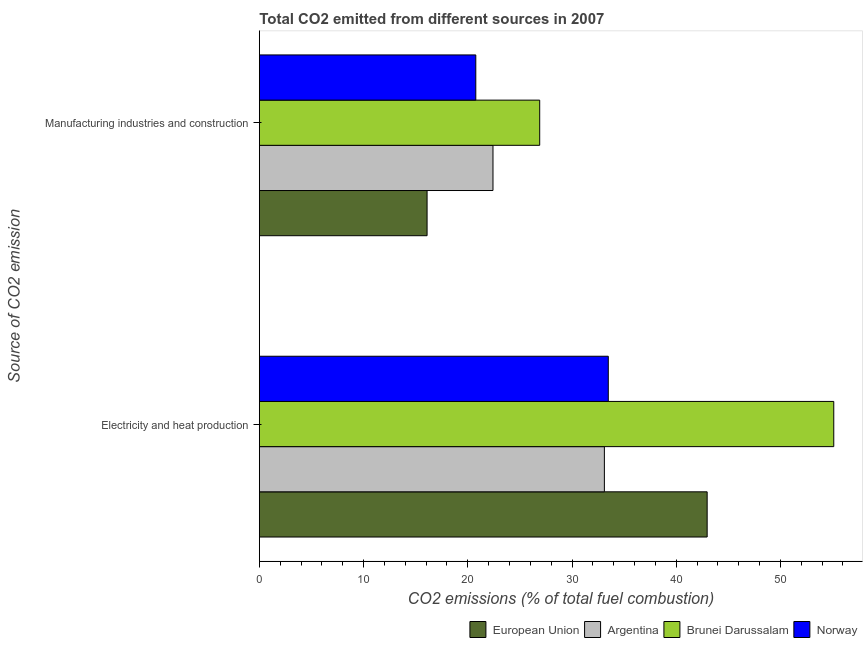Are the number of bars per tick equal to the number of legend labels?
Offer a very short reply. Yes. Are the number of bars on each tick of the Y-axis equal?
Provide a succinct answer. Yes. What is the label of the 2nd group of bars from the top?
Your answer should be very brief. Electricity and heat production. What is the co2 emissions due to electricity and heat production in European Union?
Your response must be concise. 42.97. Across all countries, what is the maximum co2 emissions due to electricity and heat production?
Give a very brief answer. 55.12. Across all countries, what is the minimum co2 emissions due to electricity and heat production?
Your response must be concise. 33.11. In which country was the co2 emissions due to electricity and heat production maximum?
Your response must be concise. Brunei Darussalam. In which country was the co2 emissions due to manufacturing industries minimum?
Provide a succinct answer. European Union. What is the total co2 emissions due to manufacturing industries in the graph?
Offer a terse response. 86.18. What is the difference between the co2 emissions due to manufacturing industries in European Union and that in Norway?
Ensure brevity in your answer.  -4.67. What is the difference between the co2 emissions due to electricity and heat production in Argentina and the co2 emissions due to manufacturing industries in European Union?
Keep it short and to the point. 17.01. What is the average co2 emissions due to manufacturing industries per country?
Keep it short and to the point. 21.55. What is the difference between the co2 emissions due to manufacturing industries and co2 emissions due to electricity and heat production in Argentina?
Your answer should be compact. -10.69. In how many countries, is the co2 emissions due to electricity and heat production greater than 54 %?
Provide a short and direct response. 1. What is the ratio of the co2 emissions due to manufacturing industries in Brunei Darussalam to that in Norway?
Give a very brief answer. 1.3. Is the co2 emissions due to electricity and heat production in Norway less than that in Argentina?
Give a very brief answer. No. In how many countries, is the co2 emissions due to manufacturing industries greater than the average co2 emissions due to manufacturing industries taken over all countries?
Your answer should be very brief. 2. What does the 1st bar from the top in Manufacturing industries and construction represents?
Give a very brief answer. Norway. Are all the bars in the graph horizontal?
Your response must be concise. Yes. Are the values on the major ticks of X-axis written in scientific E-notation?
Offer a terse response. No. Where does the legend appear in the graph?
Give a very brief answer. Bottom right. What is the title of the graph?
Give a very brief answer. Total CO2 emitted from different sources in 2007. Does "Vietnam" appear as one of the legend labels in the graph?
Your answer should be very brief. No. What is the label or title of the X-axis?
Ensure brevity in your answer.  CO2 emissions (% of total fuel combustion). What is the label or title of the Y-axis?
Your answer should be very brief. Source of CO2 emission. What is the CO2 emissions (% of total fuel combustion) in European Union in Electricity and heat production?
Your response must be concise. 42.97. What is the CO2 emissions (% of total fuel combustion) of Argentina in Electricity and heat production?
Your answer should be compact. 33.11. What is the CO2 emissions (% of total fuel combustion) of Brunei Darussalam in Electricity and heat production?
Your response must be concise. 55.12. What is the CO2 emissions (% of total fuel combustion) in Norway in Electricity and heat production?
Keep it short and to the point. 33.48. What is the CO2 emissions (% of total fuel combustion) in European Union in Manufacturing industries and construction?
Offer a terse response. 16.09. What is the CO2 emissions (% of total fuel combustion) in Argentina in Manufacturing industries and construction?
Your response must be concise. 22.42. What is the CO2 emissions (% of total fuel combustion) in Brunei Darussalam in Manufacturing industries and construction?
Your answer should be compact. 26.9. What is the CO2 emissions (% of total fuel combustion) of Norway in Manufacturing industries and construction?
Offer a very short reply. 20.77. Across all Source of CO2 emission, what is the maximum CO2 emissions (% of total fuel combustion) in European Union?
Your answer should be compact. 42.97. Across all Source of CO2 emission, what is the maximum CO2 emissions (% of total fuel combustion) of Argentina?
Your answer should be compact. 33.11. Across all Source of CO2 emission, what is the maximum CO2 emissions (% of total fuel combustion) in Brunei Darussalam?
Offer a very short reply. 55.12. Across all Source of CO2 emission, what is the maximum CO2 emissions (% of total fuel combustion) of Norway?
Make the answer very short. 33.48. Across all Source of CO2 emission, what is the minimum CO2 emissions (% of total fuel combustion) in European Union?
Your answer should be very brief. 16.09. Across all Source of CO2 emission, what is the minimum CO2 emissions (% of total fuel combustion) of Argentina?
Your answer should be compact. 22.42. Across all Source of CO2 emission, what is the minimum CO2 emissions (% of total fuel combustion) of Brunei Darussalam?
Provide a short and direct response. 26.9. Across all Source of CO2 emission, what is the minimum CO2 emissions (% of total fuel combustion) in Norway?
Offer a very short reply. 20.77. What is the total CO2 emissions (% of total fuel combustion) in European Union in the graph?
Ensure brevity in your answer.  59.06. What is the total CO2 emissions (% of total fuel combustion) of Argentina in the graph?
Your answer should be very brief. 55.52. What is the total CO2 emissions (% of total fuel combustion) in Brunei Darussalam in the graph?
Give a very brief answer. 82.02. What is the total CO2 emissions (% of total fuel combustion) in Norway in the graph?
Provide a short and direct response. 54.25. What is the difference between the CO2 emissions (% of total fuel combustion) in European Union in Electricity and heat production and that in Manufacturing industries and construction?
Provide a succinct answer. 26.87. What is the difference between the CO2 emissions (% of total fuel combustion) of Argentina in Electricity and heat production and that in Manufacturing industries and construction?
Provide a short and direct response. 10.69. What is the difference between the CO2 emissions (% of total fuel combustion) of Brunei Darussalam in Electricity and heat production and that in Manufacturing industries and construction?
Provide a succinct answer. 28.22. What is the difference between the CO2 emissions (% of total fuel combustion) in Norway in Electricity and heat production and that in Manufacturing industries and construction?
Your answer should be compact. 12.71. What is the difference between the CO2 emissions (% of total fuel combustion) of European Union in Electricity and heat production and the CO2 emissions (% of total fuel combustion) of Argentina in Manufacturing industries and construction?
Provide a succinct answer. 20.55. What is the difference between the CO2 emissions (% of total fuel combustion) in European Union in Electricity and heat production and the CO2 emissions (% of total fuel combustion) in Brunei Darussalam in Manufacturing industries and construction?
Make the answer very short. 16.07. What is the difference between the CO2 emissions (% of total fuel combustion) in European Union in Electricity and heat production and the CO2 emissions (% of total fuel combustion) in Norway in Manufacturing industries and construction?
Give a very brief answer. 22.2. What is the difference between the CO2 emissions (% of total fuel combustion) of Argentina in Electricity and heat production and the CO2 emissions (% of total fuel combustion) of Brunei Darussalam in Manufacturing industries and construction?
Make the answer very short. 6.21. What is the difference between the CO2 emissions (% of total fuel combustion) of Argentina in Electricity and heat production and the CO2 emissions (% of total fuel combustion) of Norway in Manufacturing industries and construction?
Ensure brevity in your answer.  12.34. What is the difference between the CO2 emissions (% of total fuel combustion) in Brunei Darussalam in Electricity and heat production and the CO2 emissions (% of total fuel combustion) in Norway in Manufacturing industries and construction?
Your answer should be compact. 34.35. What is the average CO2 emissions (% of total fuel combustion) in European Union per Source of CO2 emission?
Ensure brevity in your answer.  29.53. What is the average CO2 emissions (% of total fuel combustion) of Argentina per Source of CO2 emission?
Your response must be concise. 27.76. What is the average CO2 emissions (% of total fuel combustion) in Brunei Darussalam per Source of CO2 emission?
Provide a succinct answer. 41.01. What is the average CO2 emissions (% of total fuel combustion) of Norway per Source of CO2 emission?
Your answer should be very brief. 27.13. What is the difference between the CO2 emissions (% of total fuel combustion) in European Union and CO2 emissions (% of total fuel combustion) in Argentina in Electricity and heat production?
Your answer should be very brief. 9.86. What is the difference between the CO2 emissions (% of total fuel combustion) in European Union and CO2 emissions (% of total fuel combustion) in Brunei Darussalam in Electricity and heat production?
Your answer should be compact. -12.15. What is the difference between the CO2 emissions (% of total fuel combustion) of European Union and CO2 emissions (% of total fuel combustion) of Norway in Electricity and heat production?
Give a very brief answer. 9.49. What is the difference between the CO2 emissions (% of total fuel combustion) of Argentina and CO2 emissions (% of total fuel combustion) of Brunei Darussalam in Electricity and heat production?
Ensure brevity in your answer.  -22.01. What is the difference between the CO2 emissions (% of total fuel combustion) of Argentina and CO2 emissions (% of total fuel combustion) of Norway in Electricity and heat production?
Ensure brevity in your answer.  -0.38. What is the difference between the CO2 emissions (% of total fuel combustion) in Brunei Darussalam and CO2 emissions (% of total fuel combustion) in Norway in Electricity and heat production?
Your response must be concise. 21.63. What is the difference between the CO2 emissions (% of total fuel combustion) of European Union and CO2 emissions (% of total fuel combustion) of Argentina in Manufacturing industries and construction?
Ensure brevity in your answer.  -6.32. What is the difference between the CO2 emissions (% of total fuel combustion) in European Union and CO2 emissions (% of total fuel combustion) in Brunei Darussalam in Manufacturing industries and construction?
Ensure brevity in your answer.  -10.81. What is the difference between the CO2 emissions (% of total fuel combustion) of European Union and CO2 emissions (% of total fuel combustion) of Norway in Manufacturing industries and construction?
Offer a very short reply. -4.67. What is the difference between the CO2 emissions (% of total fuel combustion) in Argentina and CO2 emissions (% of total fuel combustion) in Brunei Darussalam in Manufacturing industries and construction?
Give a very brief answer. -4.48. What is the difference between the CO2 emissions (% of total fuel combustion) of Argentina and CO2 emissions (% of total fuel combustion) of Norway in Manufacturing industries and construction?
Offer a very short reply. 1.65. What is the difference between the CO2 emissions (% of total fuel combustion) of Brunei Darussalam and CO2 emissions (% of total fuel combustion) of Norway in Manufacturing industries and construction?
Your answer should be very brief. 6.13. What is the ratio of the CO2 emissions (% of total fuel combustion) in European Union in Electricity and heat production to that in Manufacturing industries and construction?
Provide a succinct answer. 2.67. What is the ratio of the CO2 emissions (% of total fuel combustion) in Argentina in Electricity and heat production to that in Manufacturing industries and construction?
Your answer should be compact. 1.48. What is the ratio of the CO2 emissions (% of total fuel combustion) in Brunei Darussalam in Electricity and heat production to that in Manufacturing industries and construction?
Keep it short and to the point. 2.05. What is the ratio of the CO2 emissions (% of total fuel combustion) of Norway in Electricity and heat production to that in Manufacturing industries and construction?
Your response must be concise. 1.61. What is the difference between the highest and the second highest CO2 emissions (% of total fuel combustion) of European Union?
Your answer should be compact. 26.87. What is the difference between the highest and the second highest CO2 emissions (% of total fuel combustion) in Argentina?
Provide a succinct answer. 10.69. What is the difference between the highest and the second highest CO2 emissions (% of total fuel combustion) of Brunei Darussalam?
Provide a short and direct response. 28.22. What is the difference between the highest and the second highest CO2 emissions (% of total fuel combustion) in Norway?
Give a very brief answer. 12.71. What is the difference between the highest and the lowest CO2 emissions (% of total fuel combustion) of European Union?
Your response must be concise. 26.87. What is the difference between the highest and the lowest CO2 emissions (% of total fuel combustion) of Argentina?
Offer a very short reply. 10.69. What is the difference between the highest and the lowest CO2 emissions (% of total fuel combustion) of Brunei Darussalam?
Your answer should be very brief. 28.22. What is the difference between the highest and the lowest CO2 emissions (% of total fuel combustion) in Norway?
Your answer should be compact. 12.71. 